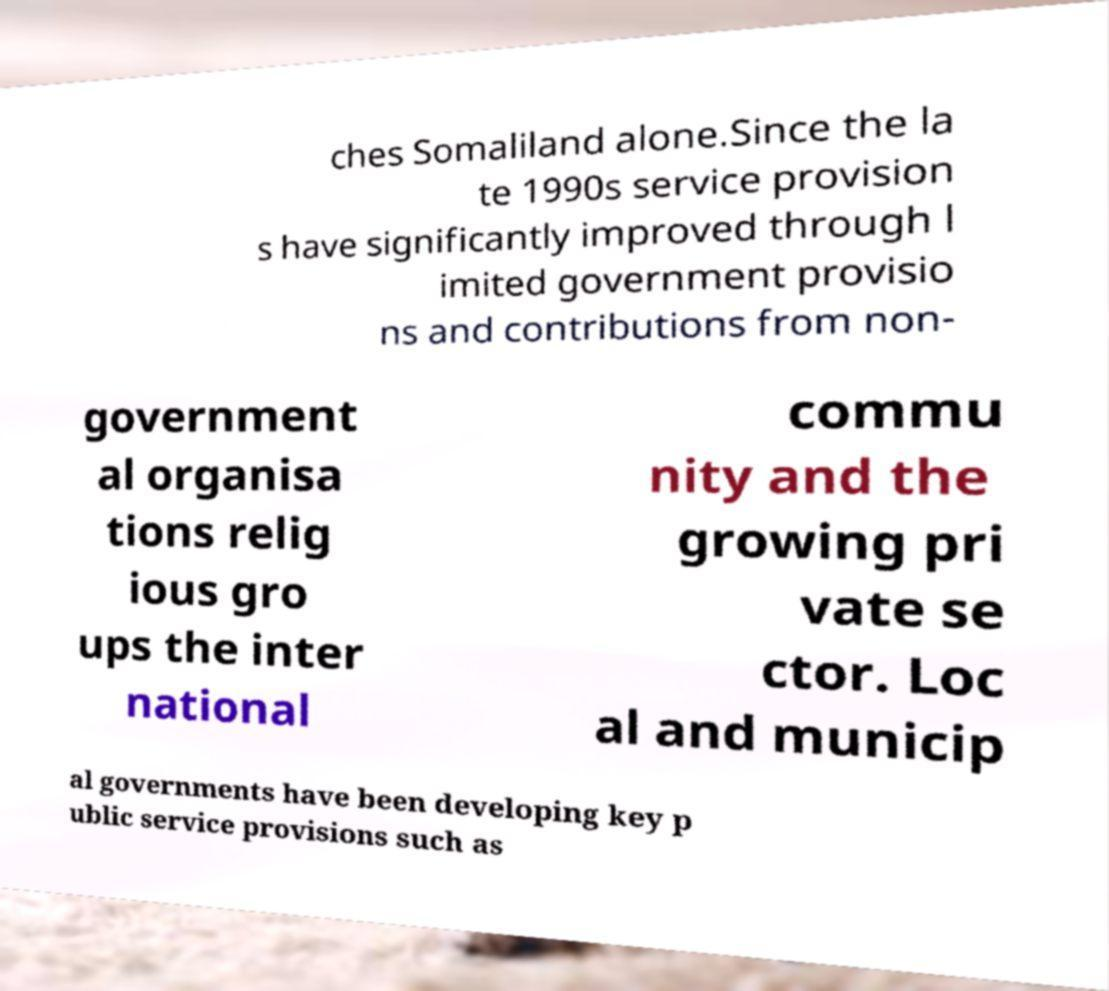I need the written content from this picture converted into text. Can you do that? ches Somaliland alone.Since the la te 1990s service provision s have significantly improved through l imited government provisio ns and contributions from non- government al organisa tions relig ious gro ups the inter national commu nity and the growing pri vate se ctor. Loc al and municip al governments have been developing key p ublic service provisions such as 